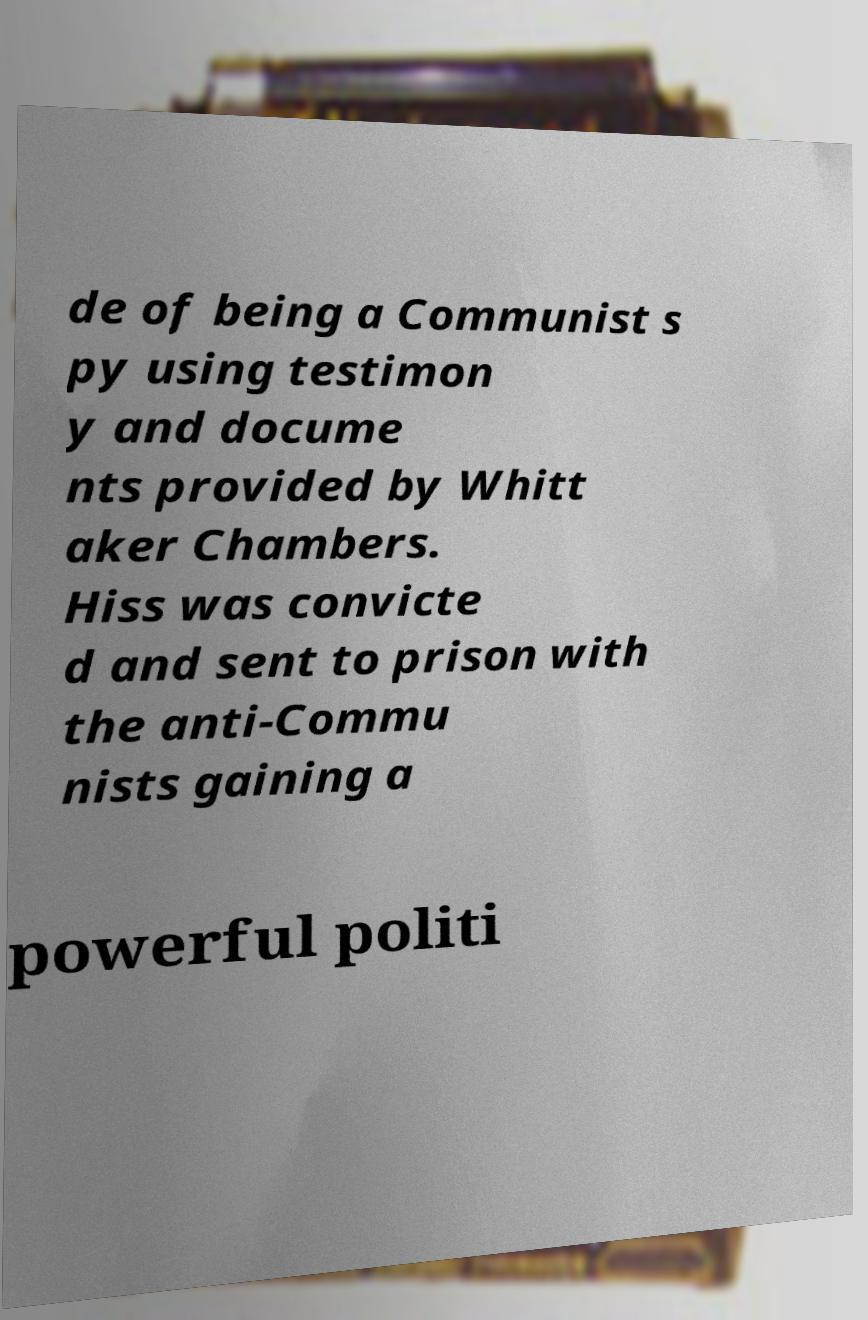Please read and relay the text visible in this image. What does it say? de of being a Communist s py using testimon y and docume nts provided by Whitt aker Chambers. Hiss was convicte d and sent to prison with the anti-Commu nists gaining a powerful politi 